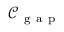<formula> <loc_0><loc_0><loc_500><loc_500>\mathcal { C } _ { g a p }</formula> 